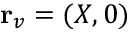<formula> <loc_0><loc_0><loc_500><loc_500>{ r } _ { v } = ( X , 0 )</formula> 